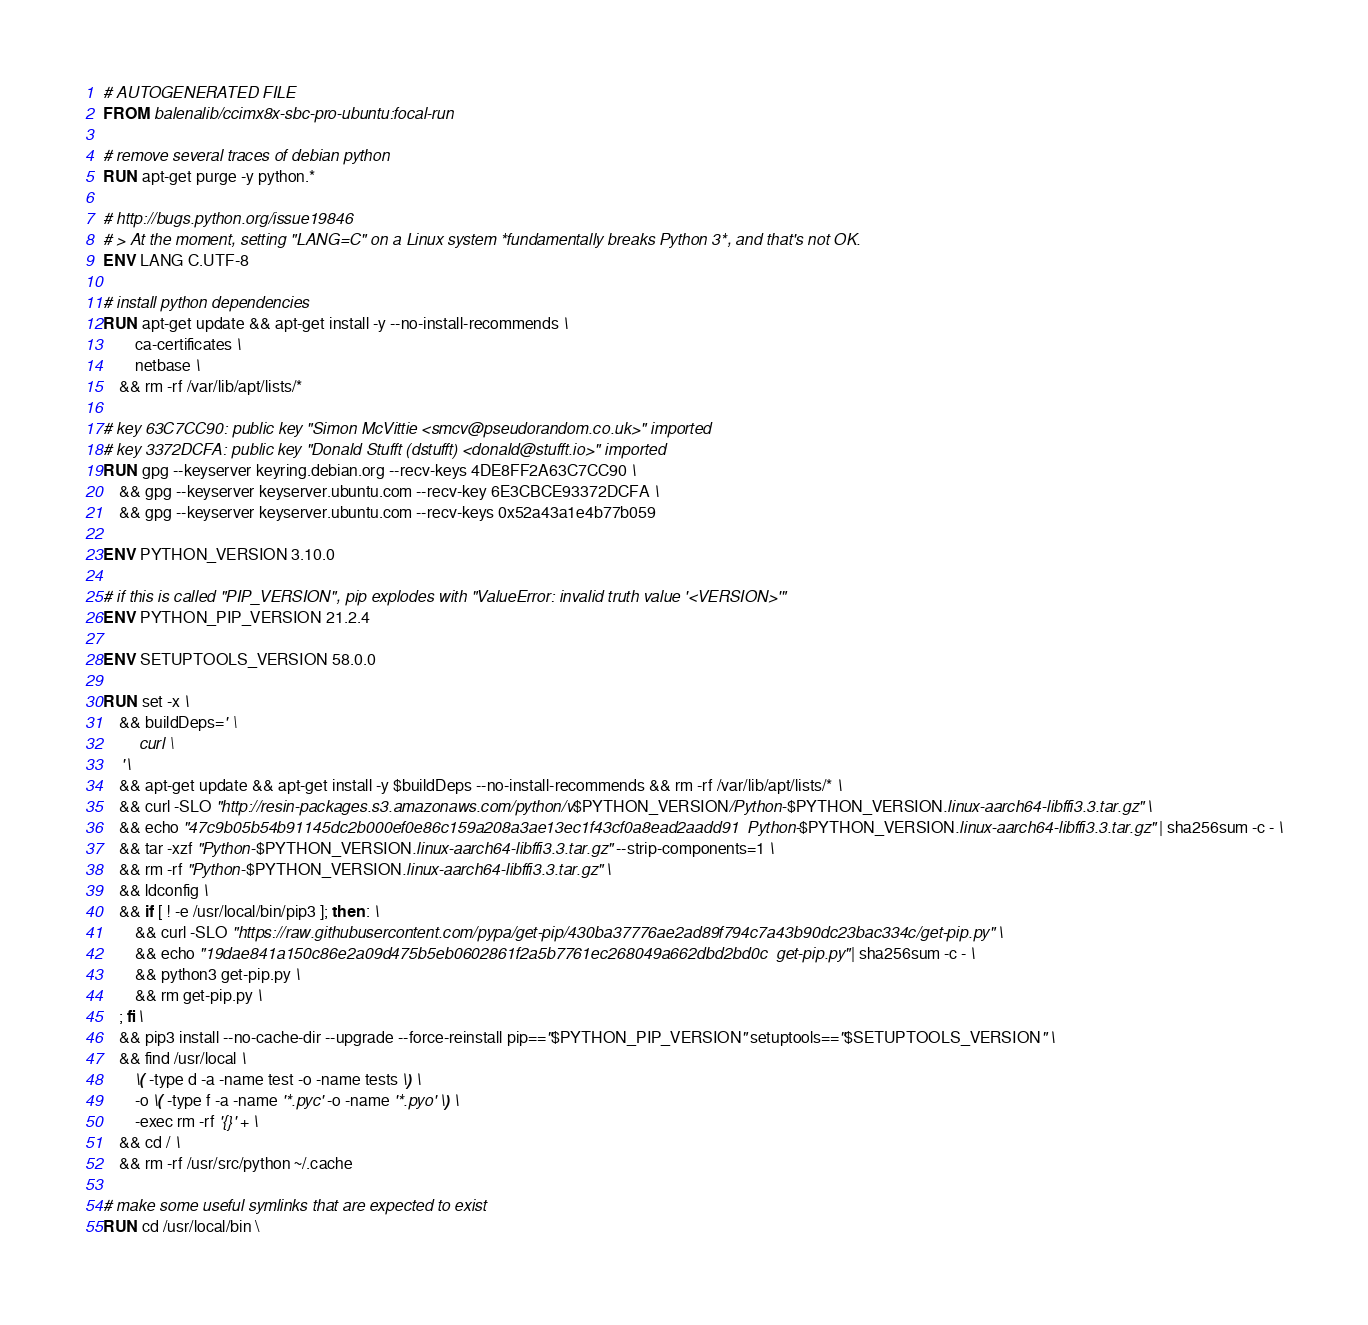<code> <loc_0><loc_0><loc_500><loc_500><_Dockerfile_># AUTOGENERATED FILE
FROM balenalib/ccimx8x-sbc-pro-ubuntu:focal-run

# remove several traces of debian python
RUN apt-get purge -y python.*

# http://bugs.python.org/issue19846
# > At the moment, setting "LANG=C" on a Linux system *fundamentally breaks Python 3*, and that's not OK.
ENV LANG C.UTF-8

# install python dependencies
RUN apt-get update && apt-get install -y --no-install-recommends \
		ca-certificates \
		netbase \
	&& rm -rf /var/lib/apt/lists/*

# key 63C7CC90: public key "Simon McVittie <smcv@pseudorandom.co.uk>" imported
# key 3372DCFA: public key "Donald Stufft (dstufft) <donald@stufft.io>" imported
RUN gpg --keyserver keyring.debian.org --recv-keys 4DE8FF2A63C7CC90 \
	&& gpg --keyserver keyserver.ubuntu.com --recv-key 6E3CBCE93372DCFA \
	&& gpg --keyserver keyserver.ubuntu.com --recv-keys 0x52a43a1e4b77b059

ENV PYTHON_VERSION 3.10.0

# if this is called "PIP_VERSION", pip explodes with "ValueError: invalid truth value '<VERSION>'"
ENV PYTHON_PIP_VERSION 21.2.4

ENV SETUPTOOLS_VERSION 58.0.0

RUN set -x \
	&& buildDeps=' \
		curl \
	' \
	&& apt-get update && apt-get install -y $buildDeps --no-install-recommends && rm -rf /var/lib/apt/lists/* \
	&& curl -SLO "http://resin-packages.s3.amazonaws.com/python/v$PYTHON_VERSION/Python-$PYTHON_VERSION.linux-aarch64-libffi3.3.tar.gz" \
	&& echo "47c9b05b54b91145dc2b000ef0e86c159a208a3ae13ec1f43cf0a8ead2aadd91  Python-$PYTHON_VERSION.linux-aarch64-libffi3.3.tar.gz" | sha256sum -c - \
	&& tar -xzf "Python-$PYTHON_VERSION.linux-aarch64-libffi3.3.tar.gz" --strip-components=1 \
	&& rm -rf "Python-$PYTHON_VERSION.linux-aarch64-libffi3.3.tar.gz" \
	&& ldconfig \
	&& if [ ! -e /usr/local/bin/pip3 ]; then : \
		&& curl -SLO "https://raw.githubusercontent.com/pypa/get-pip/430ba37776ae2ad89f794c7a43b90dc23bac334c/get-pip.py" \
		&& echo "19dae841a150c86e2a09d475b5eb0602861f2a5b7761ec268049a662dbd2bd0c  get-pip.py" | sha256sum -c - \
		&& python3 get-pip.py \
		&& rm get-pip.py \
	; fi \
	&& pip3 install --no-cache-dir --upgrade --force-reinstall pip=="$PYTHON_PIP_VERSION" setuptools=="$SETUPTOOLS_VERSION" \
	&& find /usr/local \
		\( -type d -a -name test -o -name tests \) \
		-o \( -type f -a -name '*.pyc' -o -name '*.pyo' \) \
		-exec rm -rf '{}' + \
	&& cd / \
	&& rm -rf /usr/src/python ~/.cache

# make some useful symlinks that are expected to exist
RUN cd /usr/local/bin \</code> 